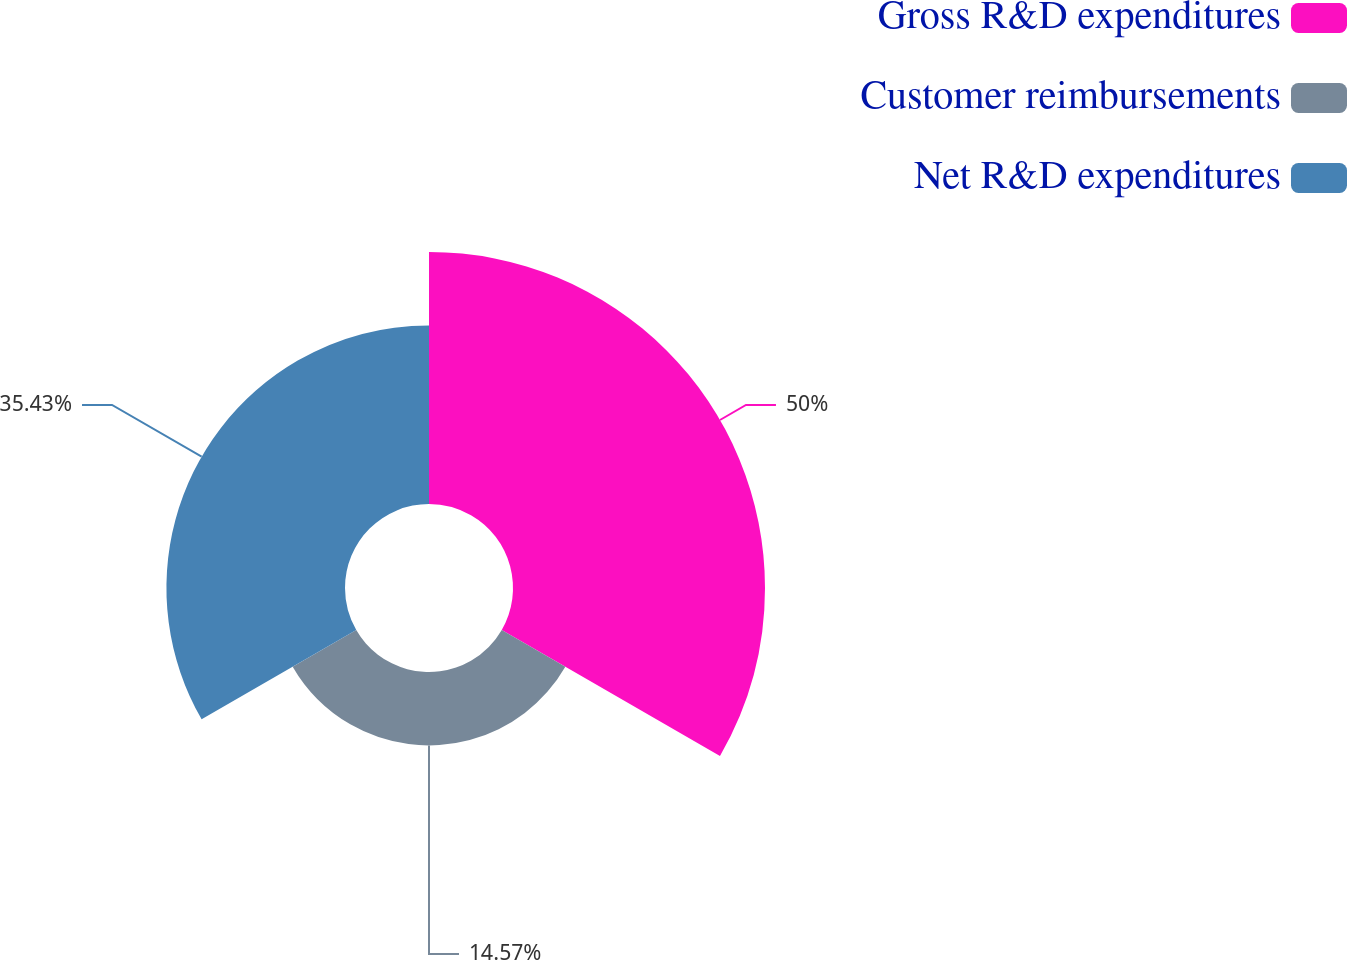<chart> <loc_0><loc_0><loc_500><loc_500><pie_chart><fcel>Gross R&D expenditures<fcel>Customer reimbursements<fcel>Net R&D expenditures<nl><fcel>50.0%<fcel>14.57%<fcel>35.43%<nl></chart> 